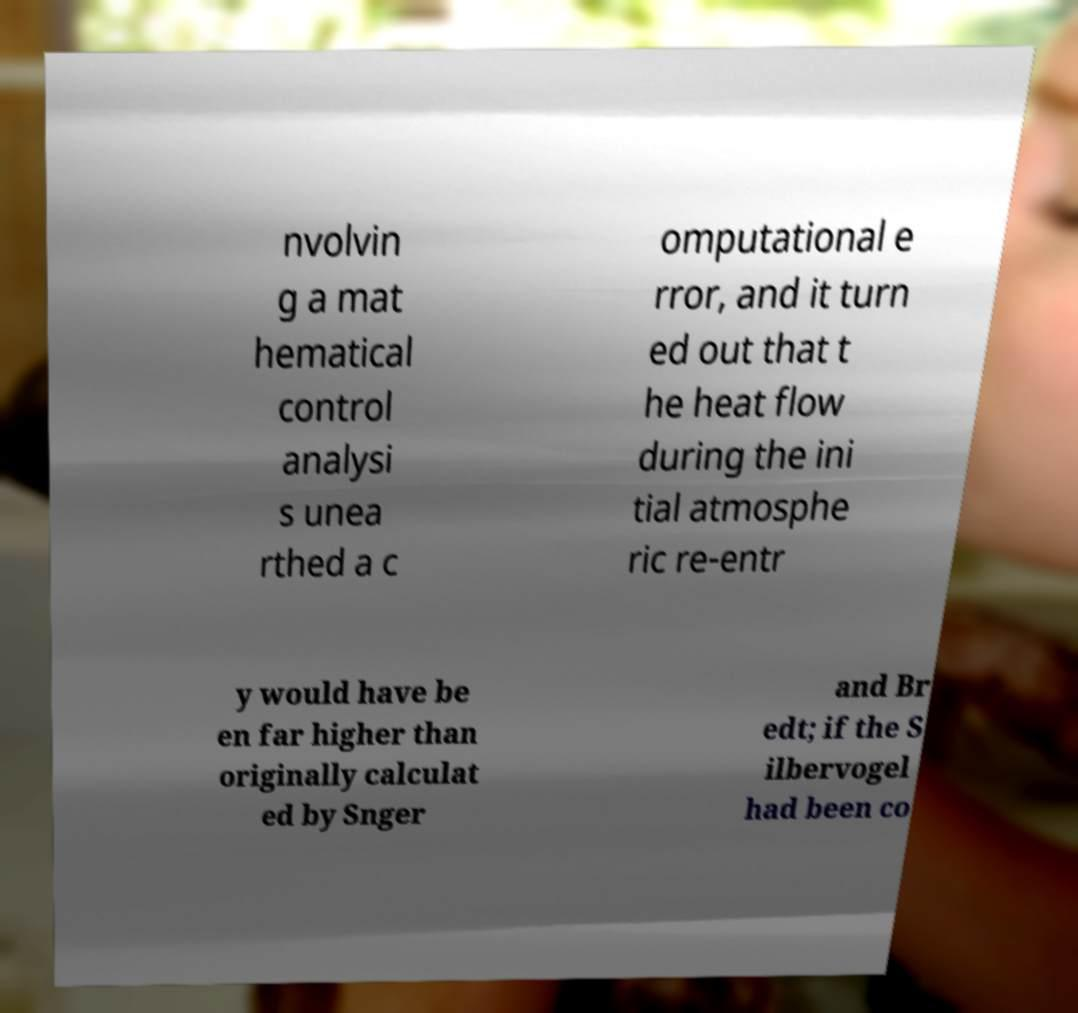Can you accurately transcribe the text from the provided image for me? nvolvin g a mat hematical control analysi s unea rthed a c omputational e rror, and it turn ed out that t he heat flow during the ini tial atmosphe ric re-entr y would have be en far higher than originally calculat ed by Snger and Br edt; if the S ilbervogel had been co 